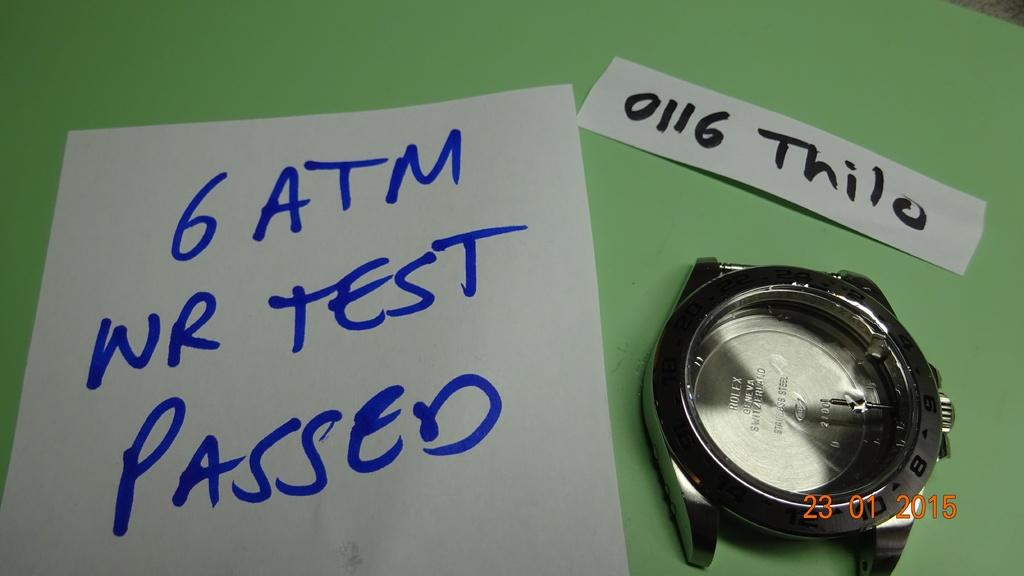How many pages are visible in the image? There are two pages in the image. What object is placed on the table in the image? A watch is placed on the table. What can be found on the pages in the image? There is text on the papers. Where is the scarecrow located in the image? There is no scarecrow present in the image. What type of lace can be seen on the pages in the image? There is no lace visible on the pages in the image; they contain text. 